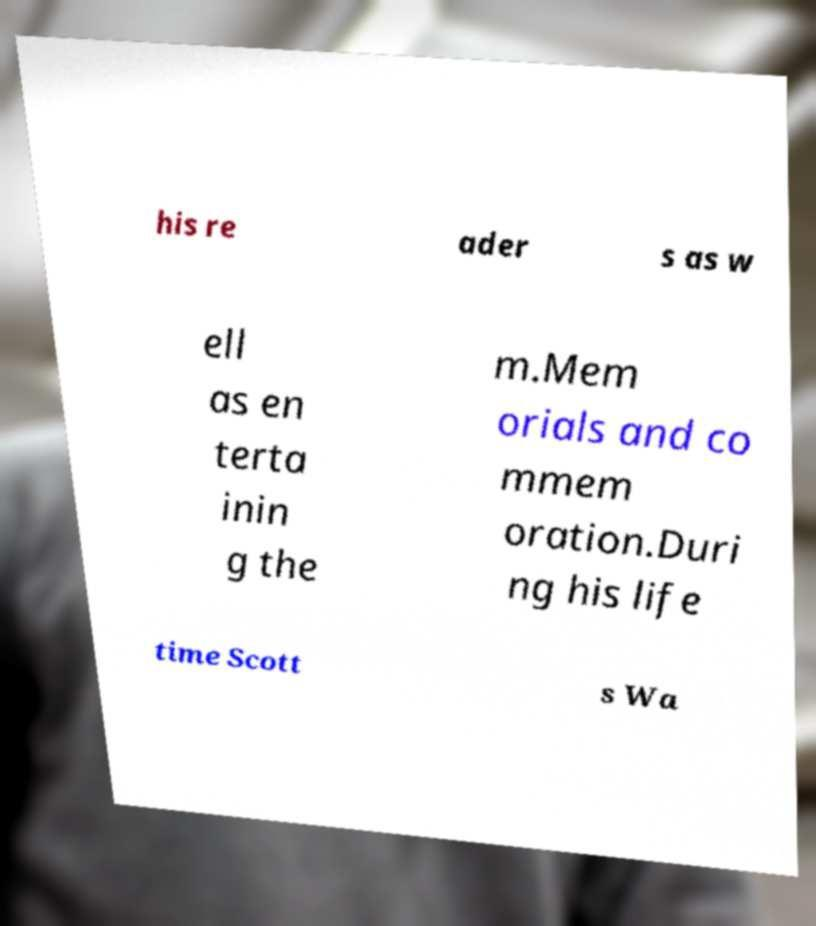For documentation purposes, I need the text within this image transcribed. Could you provide that? his re ader s as w ell as en terta inin g the m.Mem orials and co mmem oration.Duri ng his life time Scott s Wa 